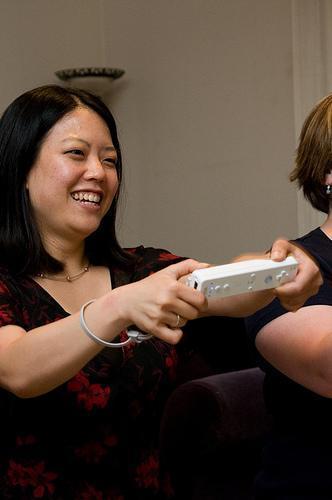How many people are visible?
Give a very brief answer. 2. How many motorcycle tires are visible?
Give a very brief answer. 0. 